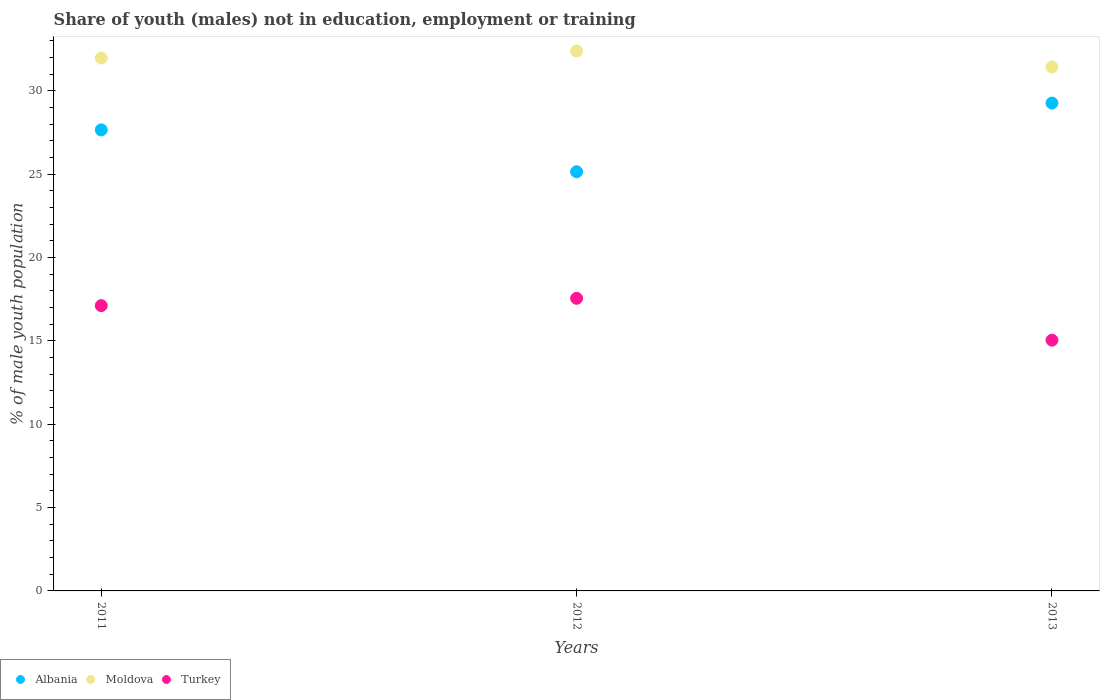Is the number of dotlines equal to the number of legend labels?
Make the answer very short. Yes. What is the percentage of unemployed males population in in Albania in 2012?
Offer a terse response. 25.14. Across all years, what is the maximum percentage of unemployed males population in in Albania?
Offer a terse response. 29.26. Across all years, what is the minimum percentage of unemployed males population in in Albania?
Offer a very short reply. 25.14. In which year was the percentage of unemployed males population in in Moldova maximum?
Your answer should be compact. 2012. What is the total percentage of unemployed males population in in Turkey in the graph?
Give a very brief answer. 49.7. What is the difference between the percentage of unemployed males population in in Turkey in 2012 and that in 2013?
Provide a succinct answer. 2.51. What is the difference between the percentage of unemployed males population in in Albania in 2011 and the percentage of unemployed males population in in Turkey in 2012?
Make the answer very short. 10.1. What is the average percentage of unemployed males population in in Moldova per year?
Offer a very short reply. 31.92. In the year 2011, what is the difference between the percentage of unemployed males population in in Albania and percentage of unemployed males population in in Turkey?
Your response must be concise. 10.54. In how many years, is the percentage of unemployed males population in in Albania greater than 21 %?
Your response must be concise. 3. What is the ratio of the percentage of unemployed males population in in Turkey in 2012 to that in 2013?
Your response must be concise. 1.17. What is the difference between the highest and the second highest percentage of unemployed males population in in Moldova?
Ensure brevity in your answer.  0.42. What is the difference between the highest and the lowest percentage of unemployed males population in in Moldova?
Give a very brief answer. 0.96. In how many years, is the percentage of unemployed males population in in Albania greater than the average percentage of unemployed males population in in Albania taken over all years?
Keep it short and to the point. 2. Is the sum of the percentage of unemployed males population in in Moldova in 2011 and 2013 greater than the maximum percentage of unemployed males population in in Albania across all years?
Make the answer very short. Yes. Does the percentage of unemployed males population in in Albania monotonically increase over the years?
Keep it short and to the point. No. Is the percentage of unemployed males population in in Moldova strictly greater than the percentage of unemployed males population in in Turkey over the years?
Give a very brief answer. Yes. Is the percentage of unemployed males population in in Turkey strictly less than the percentage of unemployed males population in in Moldova over the years?
Make the answer very short. Yes. How many years are there in the graph?
Your answer should be compact. 3. Are the values on the major ticks of Y-axis written in scientific E-notation?
Provide a short and direct response. No. Does the graph contain any zero values?
Offer a very short reply. No. Does the graph contain grids?
Give a very brief answer. No. Where does the legend appear in the graph?
Your answer should be very brief. Bottom left. How many legend labels are there?
Provide a succinct answer. 3. How are the legend labels stacked?
Provide a succinct answer. Horizontal. What is the title of the graph?
Provide a short and direct response. Share of youth (males) not in education, employment or training. What is the label or title of the Y-axis?
Make the answer very short. % of male youth population. What is the % of male youth population of Albania in 2011?
Your response must be concise. 27.65. What is the % of male youth population of Moldova in 2011?
Ensure brevity in your answer.  31.96. What is the % of male youth population of Turkey in 2011?
Your answer should be compact. 17.11. What is the % of male youth population in Albania in 2012?
Provide a succinct answer. 25.14. What is the % of male youth population of Moldova in 2012?
Provide a short and direct response. 32.38. What is the % of male youth population of Turkey in 2012?
Offer a terse response. 17.55. What is the % of male youth population in Albania in 2013?
Offer a very short reply. 29.26. What is the % of male youth population in Moldova in 2013?
Your answer should be compact. 31.42. What is the % of male youth population in Turkey in 2013?
Your response must be concise. 15.04. Across all years, what is the maximum % of male youth population in Albania?
Ensure brevity in your answer.  29.26. Across all years, what is the maximum % of male youth population in Moldova?
Make the answer very short. 32.38. Across all years, what is the maximum % of male youth population of Turkey?
Your response must be concise. 17.55. Across all years, what is the minimum % of male youth population in Albania?
Provide a short and direct response. 25.14. Across all years, what is the minimum % of male youth population in Moldova?
Your answer should be very brief. 31.42. Across all years, what is the minimum % of male youth population in Turkey?
Give a very brief answer. 15.04. What is the total % of male youth population in Albania in the graph?
Offer a terse response. 82.05. What is the total % of male youth population in Moldova in the graph?
Give a very brief answer. 95.76. What is the total % of male youth population in Turkey in the graph?
Give a very brief answer. 49.7. What is the difference between the % of male youth population in Albania in 2011 and that in 2012?
Provide a short and direct response. 2.51. What is the difference between the % of male youth population in Moldova in 2011 and that in 2012?
Your answer should be very brief. -0.42. What is the difference between the % of male youth population of Turkey in 2011 and that in 2012?
Your answer should be very brief. -0.44. What is the difference between the % of male youth population of Albania in 2011 and that in 2013?
Keep it short and to the point. -1.61. What is the difference between the % of male youth population of Moldova in 2011 and that in 2013?
Your answer should be very brief. 0.54. What is the difference between the % of male youth population of Turkey in 2011 and that in 2013?
Offer a terse response. 2.07. What is the difference between the % of male youth population in Albania in 2012 and that in 2013?
Your answer should be very brief. -4.12. What is the difference between the % of male youth population in Moldova in 2012 and that in 2013?
Your answer should be very brief. 0.96. What is the difference between the % of male youth population in Turkey in 2012 and that in 2013?
Give a very brief answer. 2.51. What is the difference between the % of male youth population of Albania in 2011 and the % of male youth population of Moldova in 2012?
Provide a succinct answer. -4.73. What is the difference between the % of male youth population in Albania in 2011 and the % of male youth population in Turkey in 2012?
Keep it short and to the point. 10.1. What is the difference between the % of male youth population of Moldova in 2011 and the % of male youth population of Turkey in 2012?
Your response must be concise. 14.41. What is the difference between the % of male youth population in Albania in 2011 and the % of male youth population in Moldova in 2013?
Your response must be concise. -3.77. What is the difference between the % of male youth population in Albania in 2011 and the % of male youth population in Turkey in 2013?
Keep it short and to the point. 12.61. What is the difference between the % of male youth population in Moldova in 2011 and the % of male youth population in Turkey in 2013?
Provide a short and direct response. 16.92. What is the difference between the % of male youth population in Albania in 2012 and the % of male youth population in Moldova in 2013?
Offer a terse response. -6.28. What is the difference between the % of male youth population of Albania in 2012 and the % of male youth population of Turkey in 2013?
Make the answer very short. 10.1. What is the difference between the % of male youth population of Moldova in 2012 and the % of male youth population of Turkey in 2013?
Keep it short and to the point. 17.34. What is the average % of male youth population of Albania per year?
Give a very brief answer. 27.35. What is the average % of male youth population in Moldova per year?
Offer a terse response. 31.92. What is the average % of male youth population in Turkey per year?
Give a very brief answer. 16.57. In the year 2011, what is the difference between the % of male youth population in Albania and % of male youth population in Moldova?
Your answer should be very brief. -4.31. In the year 2011, what is the difference between the % of male youth population of Albania and % of male youth population of Turkey?
Ensure brevity in your answer.  10.54. In the year 2011, what is the difference between the % of male youth population in Moldova and % of male youth population in Turkey?
Offer a terse response. 14.85. In the year 2012, what is the difference between the % of male youth population of Albania and % of male youth population of Moldova?
Ensure brevity in your answer.  -7.24. In the year 2012, what is the difference between the % of male youth population in Albania and % of male youth population in Turkey?
Give a very brief answer. 7.59. In the year 2012, what is the difference between the % of male youth population in Moldova and % of male youth population in Turkey?
Provide a succinct answer. 14.83. In the year 2013, what is the difference between the % of male youth population in Albania and % of male youth population in Moldova?
Provide a succinct answer. -2.16. In the year 2013, what is the difference between the % of male youth population in Albania and % of male youth population in Turkey?
Keep it short and to the point. 14.22. In the year 2013, what is the difference between the % of male youth population of Moldova and % of male youth population of Turkey?
Your answer should be compact. 16.38. What is the ratio of the % of male youth population in Albania in 2011 to that in 2012?
Your answer should be very brief. 1.1. What is the ratio of the % of male youth population in Moldova in 2011 to that in 2012?
Provide a short and direct response. 0.99. What is the ratio of the % of male youth population of Turkey in 2011 to that in 2012?
Provide a short and direct response. 0.97. What is the ratio of the % of male youth population of Albania in 2011 to that in 2013?
Your answer should be very brief. 0.94. What is the ratio of the % of male youth population of Moldova in 2011 to that in 2013?
Offer a very short reply. 1.02. What is the ratio of the % of male youth population of Turkey in 2011 to that in 2013?
Offer a very short reply. 1.14. What is the ratio of the % of male youth population in Albania in 2012 to that in 2013?
Offer a very short reply. 0.86. What is the ratio of the % of male youth population of Moldova in 2012 to that in 2013?
Make the answer very short. 1.03. What is the ratio of the % of male youth population of Turkey in 2012 to that in 2013?
Make the answer very short. 1.17. What is the difference between the highest and the second highest % of male youth population in Albania?
Offer a very short reply. 1.61. What is the difference between the highest and the second highest % of male youth population of Moldova?
Offer a very short reply. 0.42. What is the difference between the highest and the second highest % of male youth population of Turkey?
Provide a succinct answer. 0.44. What is the difference between the highest and the lowest % of male youth population in Albania?
Offer a very short reply. 4.12. What is the difference between the highest and the lowest % of male youth population of Turkey?
Provide a short and direct response. 2.51. 